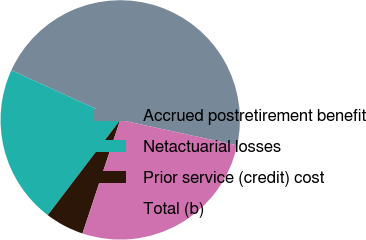Convert chart to OTSL. <chart><loc_0><loc_0><loc_500><loc_500><pie_chart><fcel>Accrued postretirement benefit<fcel>Netactuarial losses<fcel>Prior service (credit) cost<fcel>Total (b)<nl><fcel>46.6%<fcel>21.45%<fcel>5.25%<fcel>26.7%<nl></chart> 